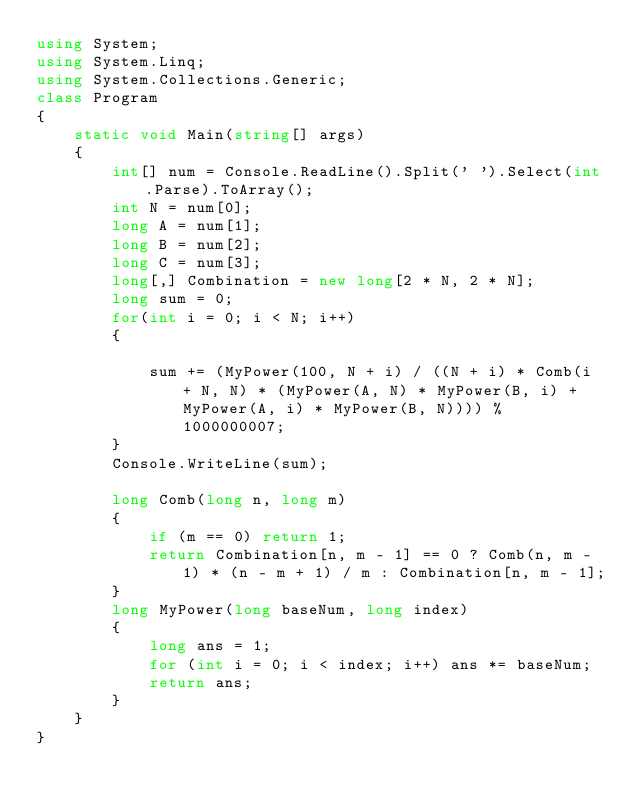<code> <loc_0><loc_0><loc_500><loc_500><_C#_>using System;
using System.Linq;
using System.Collections.Generic;
class Program
{
    static void Main(string[] args)
    {
        int[] num = Console.ReadLine().Split(' ').Select(int.Parse).ToArray();
        int N = num[0];
        long A = num[1];
        long B = num[2];
        long C = num[3];
        long[,] Combination = new long[2 * N, 2 * N]; 
        long sum = 0;
        for(int i = 0; i < N; i++)
        {

            sum += (MyPower(100, N + i) / ((N + i) * Comb(i + N, N) * (MyPower(A, N) * MyPower(B, i) + MyPower(A, i) * MyPower(B, N)))) % 1000000007;
        }
        Console.WriteLine(sum);

        long Comb(long n, long m)
        {
            if (m == 0) return 1;
            return Combination[n, m - 1] == 0 ? Comb(n, m - 1) * (n - m + 1) / m : Combination[n, m - 1];
        }
        long MyPower(long baseNum, long index)
        {
            long ans = 1;
            for (int i = 0; i < index; i++) ans *= baseNum;
            return ans;
        }
    }
}</code> 